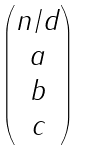<formula> <loc_0><loc_0><loc_500><loc_500>\begin{pmatrix} n / d \\ a \\ b \\ c \end{pmatrix}</formula> 